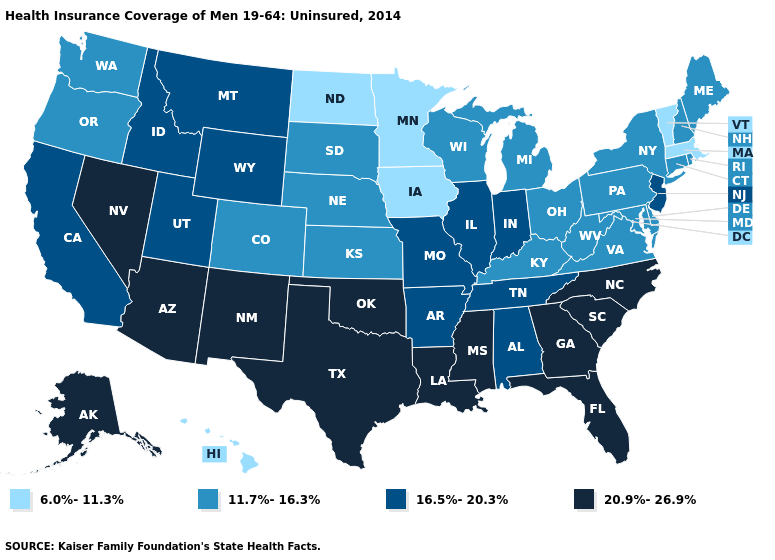What is the lowest value in the USA?
Keep it brief. 6.0%-11.3%. What is the lowest value in the MidWest?
Answer briefly. 6.0%-11.3%. Among the states that border Vermont , does Massachusetts have the highest value?
Write a very short answer. No. What is the value of Alabama?
Answer briefly. 16.5%-20.3%. Name the states that have a value in the range 16.5%-20.3%?
Answer briefly. Alabama, Arkansas, California, Idaho, Illinois, Indiana, Missouri, Montana, New Jersey, Tennessee, Utah, Wyoming. Name the states that have a value in the range 11.7%-16.3%?
Concise answer only. Colorado, Connecticut, Delaware, Kansas, Kentucky, Maine, Maryland, Michigan, Nebraska, New Hampshire, New York, Ohio, Oregon, Pennsylvania, Rhode Island, South Dakota, Virginia, Washington, West Virginia, Wisconsin. Name the states that have a value in the range 16.5%-20.3%?
Short answer required. Alabama, Arkansas, California, Idaho, Illinois, Indiana, Missouri, Montana, New Jersey, Tennessee, Utah, Wyoming. Name the states that have a value in the range 6.0%-11.3%?
Concise answer only. Hawaii, Iowa, Massachusetts, Minnesota, North Dakota, Vermont. What is the value of Missouri?
Quick response, please. 16.5%-20.3%. What is the highest value in states that border West Virginia?
Short answer required. 11.7%-16.3%. Name the states that have a value in the range 16.5%-20.3%?
Concise answer only. Alabama, Arkansas, California, Idaho, Illinois, Indiana, Missouri, Montana, New Jersey, Tennessee, Utah, Wyoming. Does North Carolina have a lower value than North Dakota?
Answer briefly. No. Name the states that have a value in the range 16.5%-20.3%?
Quick response, please. Alabama, Arkansas, California, Idaho, Illinois, Indiana, Missouri, Montana, New Jersey, Tennessee, Utah, Wyoming. Does Idaho have a higher value than Montana?
Short answer required. No. What is the value of Minnesota?
Give a very brief answer. 6.0%-11.3%. 